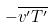<formula> <loc_0><loc_0><loc_500><loc_500>- \overline { v ^ { \prime } T ^ { \prime } }</formula> 